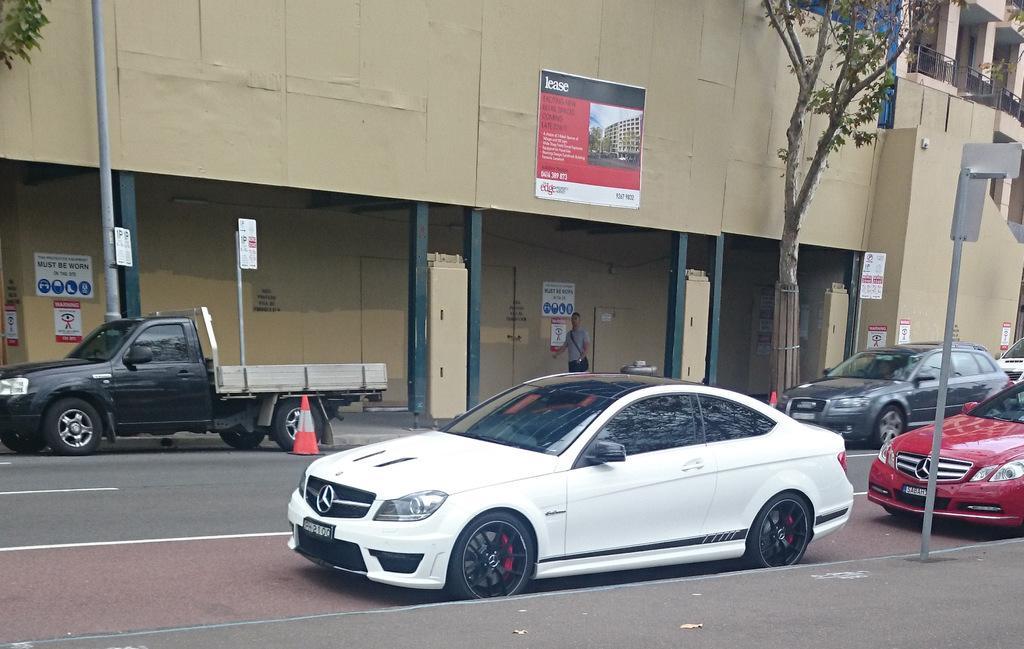Could you give a brief overview of what you see in this image? In this picture I can see buildings and few boards to the poles and I can see cars and a mini truck parked and I can see trees and few posters with some text and a human is walking. 